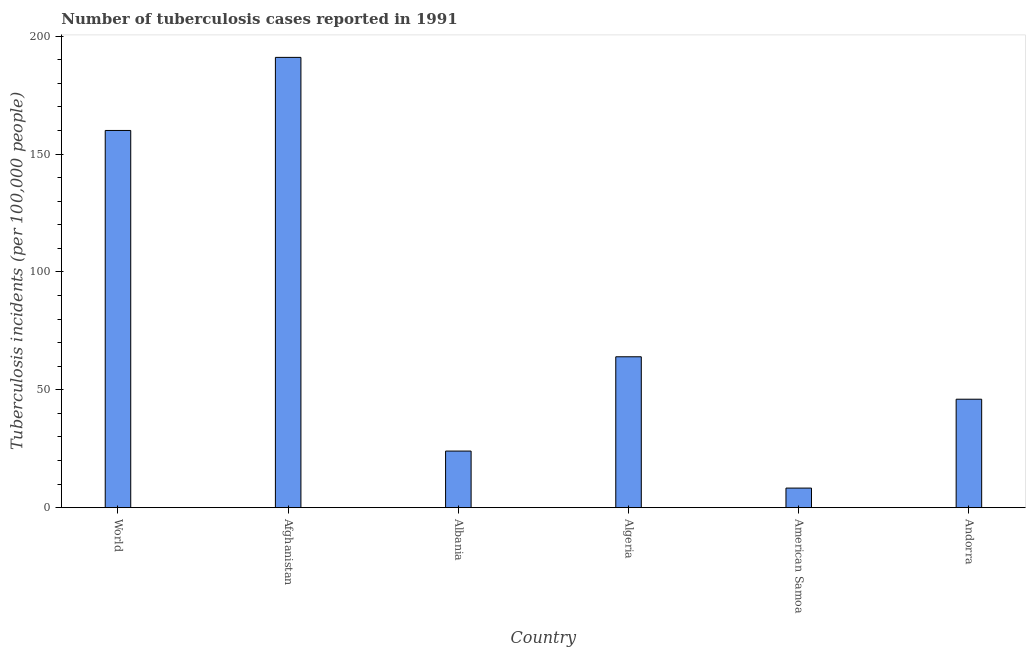What is the title of the graph?
Offer a terse response. Number of tuberculosis cases reported in 1991. What is the label or title of the X-axis?
Provide a succinct answer. Country. What is the label or title of the Y-axis?
Give a very brief answer. Tuberculosis incidents (per 100,0 people). What is the number of tuberculosis incidents in Afghanistan?
Your answer should be compact. 191. Across all countries, what is the maximum number of tuberculosis incidents?
Your answer should be very brief. 191. Across all countries, what is the minimum number of tuberculosis incidents?
Offer a very short reply. 8.3. In which country was the number of tuberculosis incidents maximum?
Provide a short and direct response. Afghanistan. In which country was the number of tuberculosis incidents minimum?
Keep it short and to the point. American Samoa. What is the sum of the number of tuberculosis incidents?
Your answer should be very brief. 493.3. What is the average number of tuberculosis incidents per country?
Your response must be concise. 82.22. What is the ratio of the number of tuberculosis incidents in Afghanistan to that in Albania?
Provide a short and direct response. 7.96. Is the number of tuberculosis incidents in Afghanistan less than that in World?
Your answer should be compact. No. Is the difference between the number of tuberculosis incidents in Albania and World greater than the difference between any two countries?
Provide a short and direct response. No. What is the difference between the highest and the second highest number of tuberculosis incidents?
Give a very brief answer. 31. What is the difference between the highest and the lowest number of tuberculosis incidents?
Your answer should be very brief. 182.7. How many bars are there?
Offer a terse response. 6. Are all the bars in the graph horizontal?
Offer a terse response. No. How many countries are there in the graph?
Offer a terse response. 6. What is the Tuberculosis incidents (per 100,000 people) of World?
Your response must be concise. 160. What is the Tuberculosis incidents (per 100,000 people) of Afghanistan?
Make the answer very short. 191. What is the difference between the Tuberculosis incidents (per 100,000 people) in World and Afghanistan?
Offer a very short reply. -31. What is the difference between the Tuberculosis incidents (per 100,000 people) in World and Albania?
Your response must be concise. 136. What is the difference between the Tuberculosis incidents (per 100,000 people) in World and Algeria?
Ensure brevity in your answer.  96. What is the difference between the Tuberculosis incidents (per 100,000 people) in World and American Samoa?
Ensure brevity in your answer.  151.7. What is the difference between the Tuberculosis incidents (per 100,000 people) in World and Andorra?
Provide a short and direct response. 114. What is the difference between the Tuberculosis incidents (per 100,000 people) in Afghanistan and Albania?
Give a very brief answer. 167. What is the difference between the Tuberculosis incidents (per 100,000 people) in Afghanistan and Algeria?
Your answer should be very brief. 127. What is the difference between the Tuberculosis incidents (per 100,000 people) in Afghanistan and American Samoa?
Provide a succinct answer. 182.7. What is the difference between the Tuberculosis incidents (per 100,000 people) in Afghanistan and Andorra?
Provide a short and direct response. 145. What is the difference between the Tuberculosis incidents (per 100,000 people) in Albania and Algeria?
Provide a succinct answer. -40. What is the difference between the Tuberculosis incidents (per 100,000 people) in Albania and American Samoa?
Ensure brevity in your answer.  15.7. What is the difference between the Tuberculosis incidents (per 100,000 people) in Algeria and American Samoa?
Your response must be concise. 55.7. What is the difference between the Tuberculosis incidents (per 100,000 people) in Algeria and Andorra?
Give a very brief answer. 18. What is the difference between the Tuberculosis incidents (per 100,000 people) in American Samoa and Andorra?
Provide a short and direct response. -37.7. What is the ratio of the Tuberculosis incidents (per 100,000 people) in World to that in Afghanistan?
Provide a short and direct response. 0.84. What is the ratio of the Tuberculosis incidents (per 100,000 people) in World to that in Albania?
Your response must be concise. 6.67. What is the ratio of the Tuberculosis incidents (per 100,000 people) in World to that in American Samoa?
Provide a succinct answer. 19.28. What is the ratio of the Tuberculosis incidents (per 100,000 people) in World to that in Andorra?
Your answer should be compact. 3.48. What is the ratio of the Tuberculosis incidents (per 100,000 people) in Afghanistan to that in Albania?
Give a very brief answer. 7.96. What is the ratio of the Tuberculosis incidents (per 100,000 people) in Afghanistan to that in Algeria?
Give a very brief answer. 2.98. What is the ratio of the Tuberculosis incidents (per 100,000 people) in Afghanistan to that in American Samoa?
Make the answer very short. 23.01. What is the ratio of the Tuberculosis incidents (per 100,000 people) in Afghanistan to that in Andorra?
Offer a terse response. 4.15. What is the ratio of the Tuberculosis incidents (per 100,000 people) in Albania to that in Algeria?
Keep it short and to the point. 0.38. What is the ratio of the Tuberculosis incidents (per 100,000 people) in Albania to that in American Samoa?
Provide a short and direct response. 2.89. What is the ratio of the Tuberculosis incidents (per 100,000 people) in Albania to that in Andorra?
Offer a terse response. 0.52. What is the ratio of the Tuberculosis incidents (per 100,000 people) in Algeria to that in American Samoa?
Offer a very short reply. 7.71. What is the ratio of the Tuberculosis incidents (per 100,000 people) in Algeria to that in Andorra?
Your answer should be very brief. 1.39. What is the ratio of the Tuberculosis incidents (per 100,000 people) in American Samoa to that in Andorra?
Your response must be concise. 0.18. 